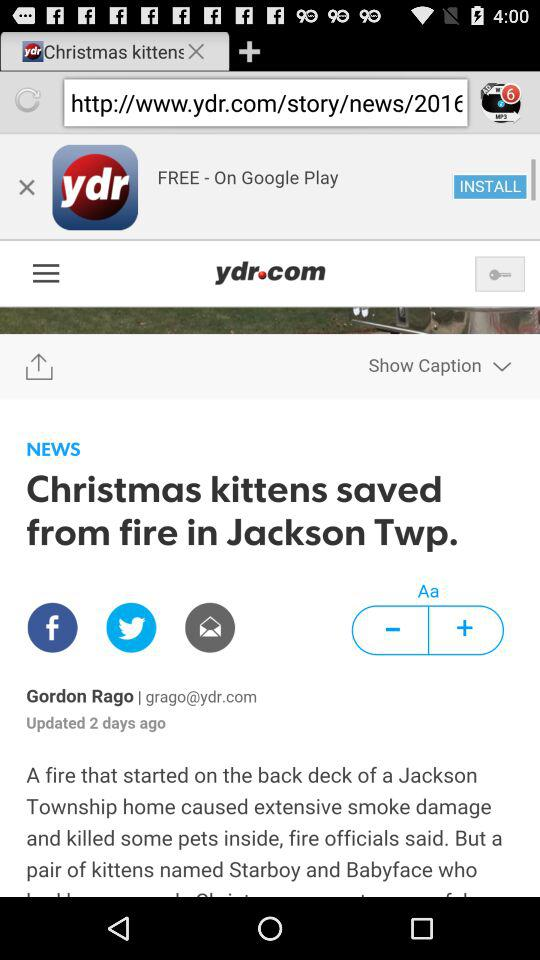What is the email ID of the author? The email ID of the author is grago@ydr.com. 